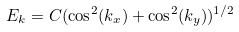<formula> <loc_0><loc_0><loc_500><loc_500>E _ { k } = C ( \cos ^ { 2 } ( k _ { x } ) + \cos ^ { 2 } ( k _ { y } ) ) ^ { 1 / 2 }</formula> 